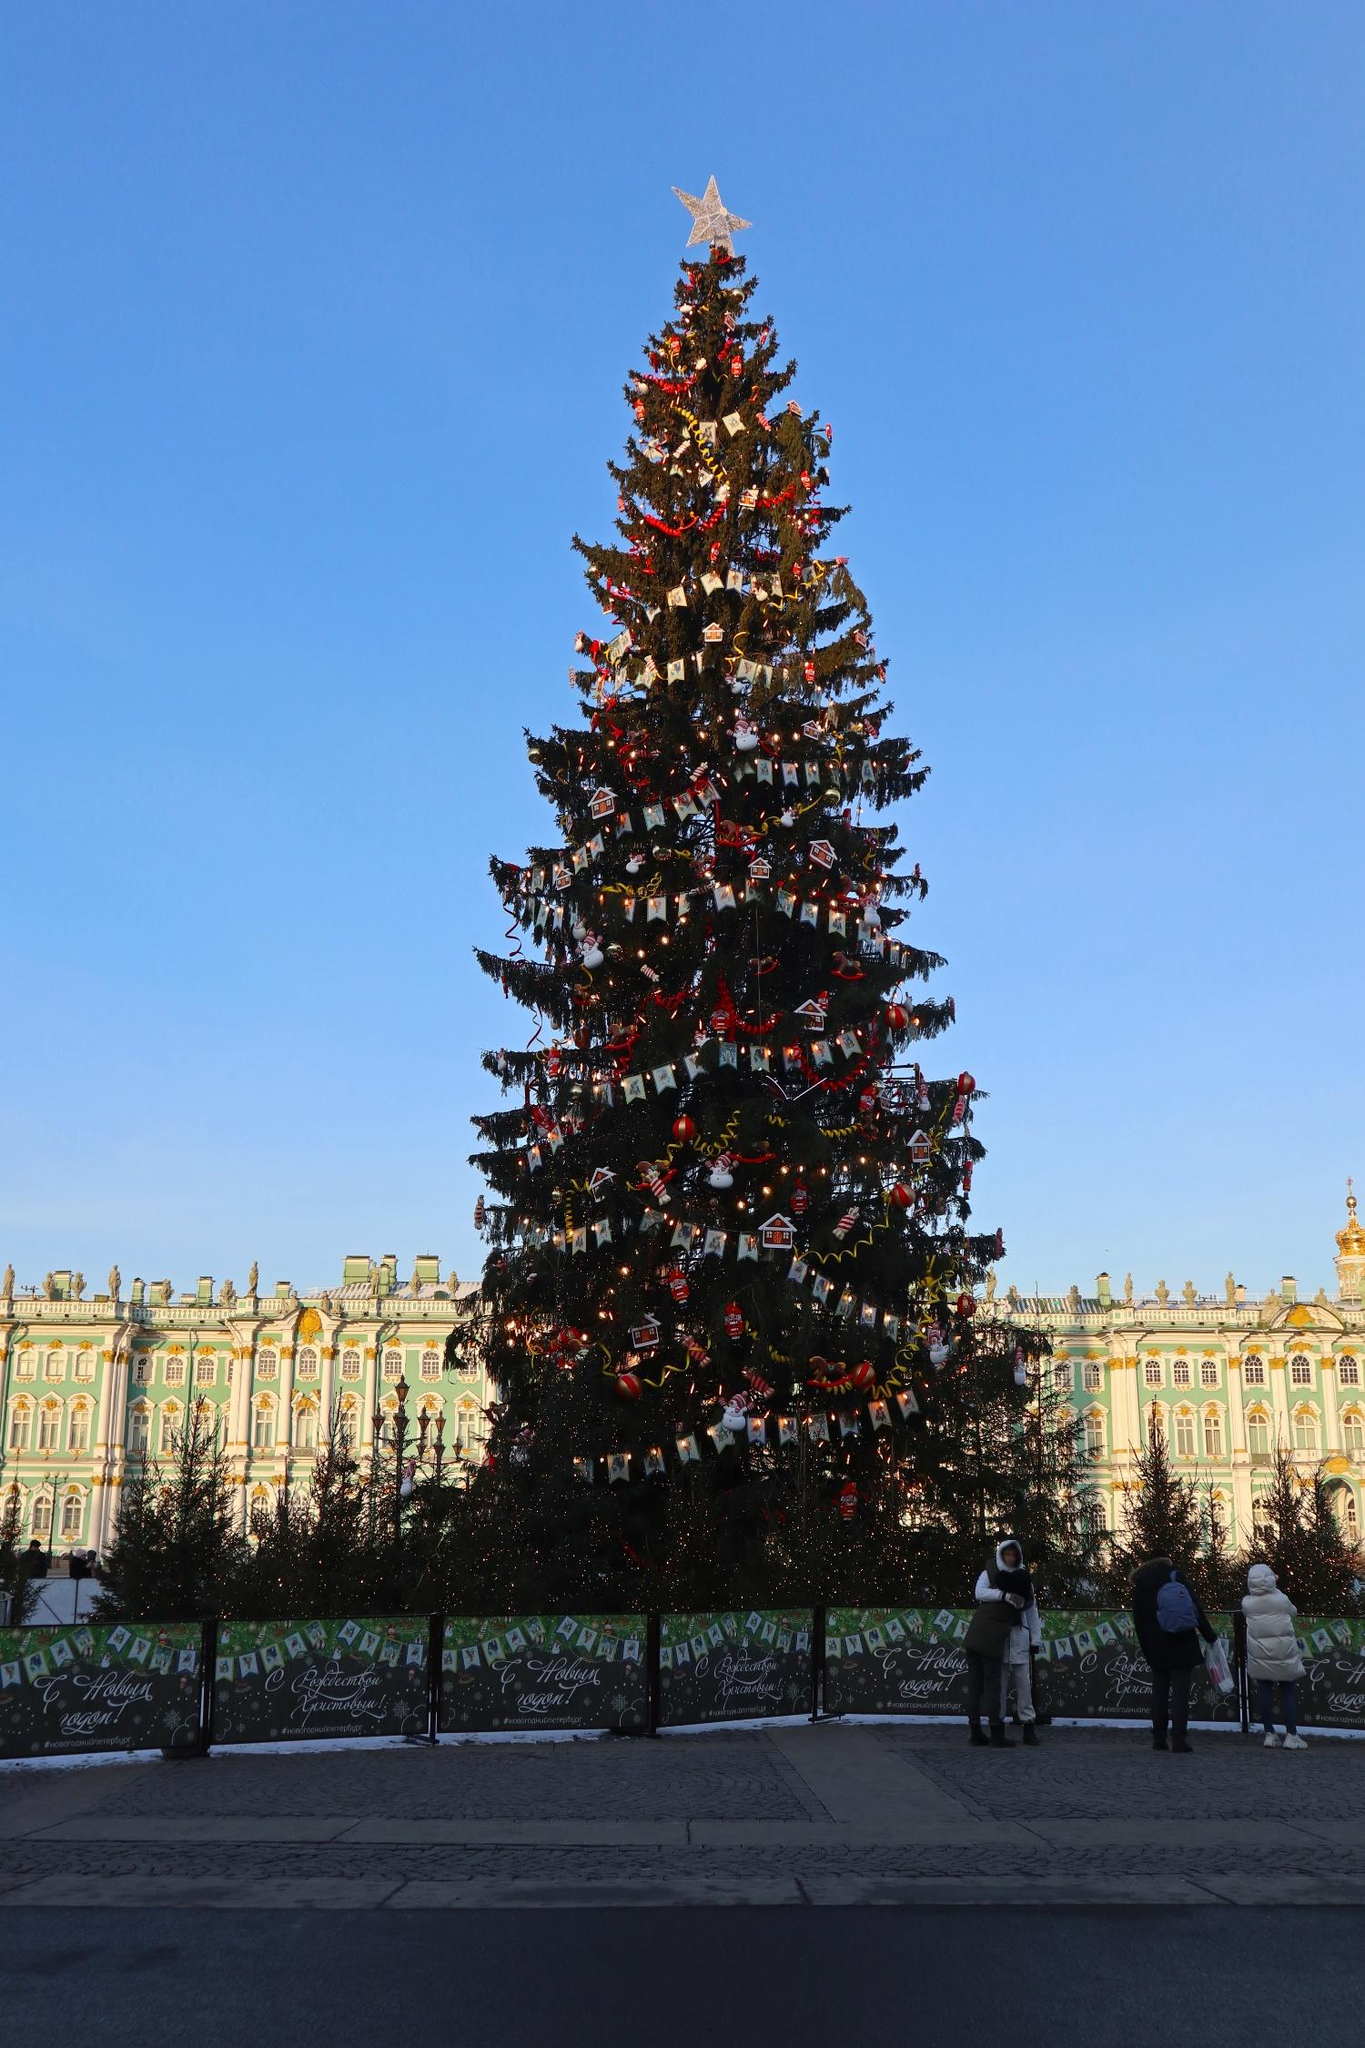Describe the feelings evoked by the scene. The scene evokes a sense of wonder and festive joy. The towering Christmas tree, with its radiant ornaments and golden star, brings a feeling of holiday magic and warmth. The intricate design of the building in the background adds a historical and cultural depth, fostering a sense of respect and admiration for tradition. The presence of people near the tree further imparts a feeling of community and shared celebratory spirit, highlighting the unifying power of holiday festivities. What do you think are the stories behind the people in the image? Imagine the individuals near the tree as long-time friends who have come together to enjoy the holiday season. Perhaps they have made it a yearly tradition to visit this Christmas tree, reminiscing about past holidays and creating new memories. Each person might have their own unique reason for being there—one could be a local who cherishes the tree as a symbol of home, while another could be a visitor marveling at the festive spectacle for the first time. Their shared moment by the tree encapsulates the timeless spirit of togetherness that the holidays bring. 